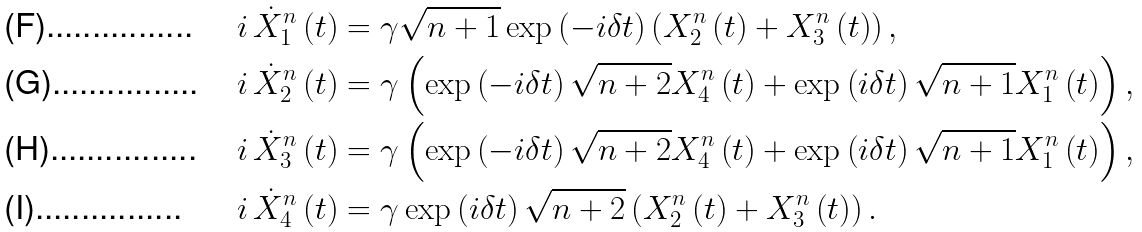<formula> <loc_0><loc_0><loc_500><loc_500>i \, \dot { X } _ { 1 } ^ { n } \left ( t \right ) & = \gamma \sqrt { n + 1 } \exp \left ( - i \delta t \right ) \left ( X _ { 2 } ^ { n } \left ( t \right ) + X _ { 3 } ^ { n } \left ( t \right ) \right ) , \\ i \, \dot { X } _ { 2 } ^ { n } \left ( t \right ) & = \gamma \left ( \exp \left ( - i \delta t \right ) \sqrt { n + 2 } X _ { 4 } ^ { n } \left ( t \right ) + \exp \left ( i \delta t \right ) \sqrt { n + 1 } X _ { 1 } ^ { n } \left ( t \right ) \right ) , \\ i \, \dot { X } _ { 3 } ^ { n } \left ( t \right ) & = \gamma \left ( \exp \left ( - i \delta t \right ) \sqrt { n + 2 } X _ { 4 } ^ { n } \left ( t \right ) + \exp \left ( i \delta t \right ) \sqrt { n + 1 } X _ { 1 } ^ { n } \left ( t \right ) \right ) , \\ i \, \dot { X } _ { 4 } ^ { n } \left ( t \right ) & = \gamma \exp \left ( i \delta t \right ) \sqrt { n + 2 } \left ( X _ { 2 } ^ { n } \left ( t \right ) + X _ { 3 } ^ { n } \left ( t \right ) \right ) .</formula> 